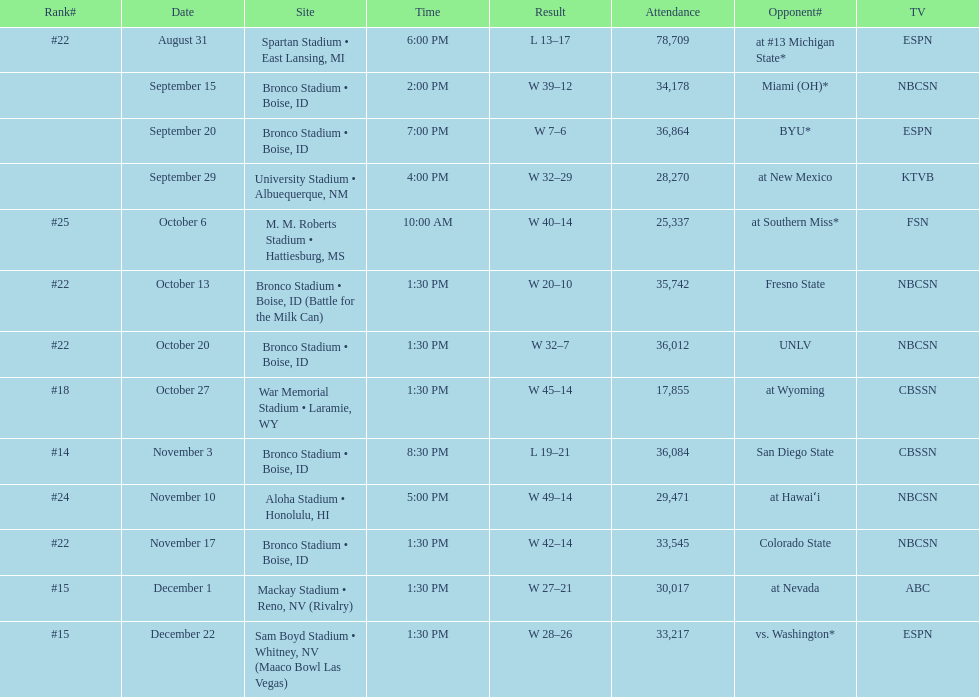What rank was boise state after november 10th? #22. 